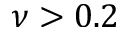<formula> <loc_0><loc_0><loc_500><loc_500>\nu > 0 . 2</formula> 